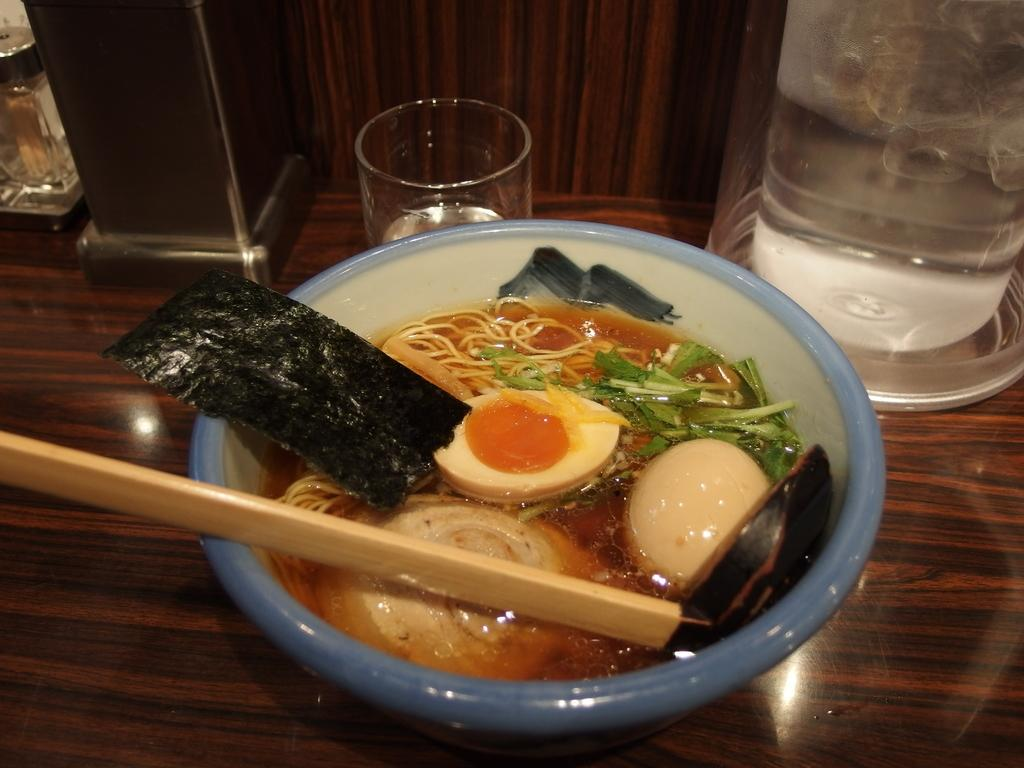What type of food is in the bowl in the image? There are cooked food items in a bowl in the image, specifically soup. What is the glass near the bowl used for? The glass near the bowl might be used for drinking or holding a beverage. Can you describe the other objects around the bowl? Unfortunately, the provided facts do not give specific details about the other objects around the bowl. How many girls are giving a haircut to the manager in the image? There are no girls or managers present in the image, and therefore no haircuts are being given. 